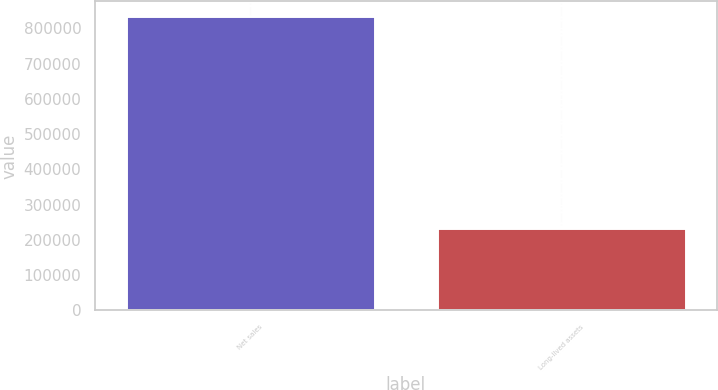<chart> <loc_0><loc_0><loc_500><loc_500><bar_chart><fcel>Net sales<fcel>Long-lived assets<nl><fcel>834437<fcel>232691<nl></chart> 